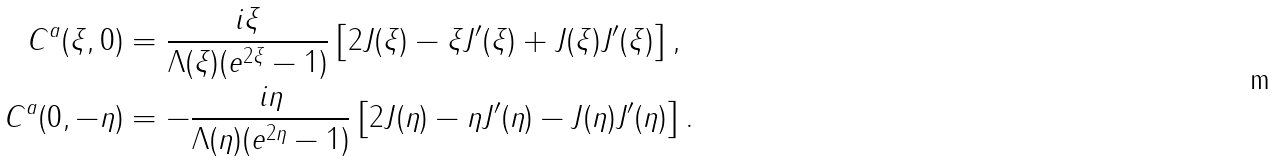<formula> <loc_0><loc_0><loc_500><loc_500>C ^ { a } ( \xi , 0 ) & = \frac { i \xi } { \Lambda ( \xi ) ( e ^ { 2 \xi } - 1 ) } \left [ 2 J ( \xi ) - \xi J ^ { \prime } ( \xi ) + J ( \xi ) J ^ { \prime } ( \xi ) \right ] , \\ C ^ { a } ( 0 , - \eta ) & = - \frac { i \eta } { \Lambda ( \eta ) ( e ^ { 2 \eta } - 1 ) } \left [ 2 J ( \eta ) - \eta J ^ { \prime } ( \eta ) - J ( \eta ) J ^ { \prime } ( \eta ) \right ] .</formula> 